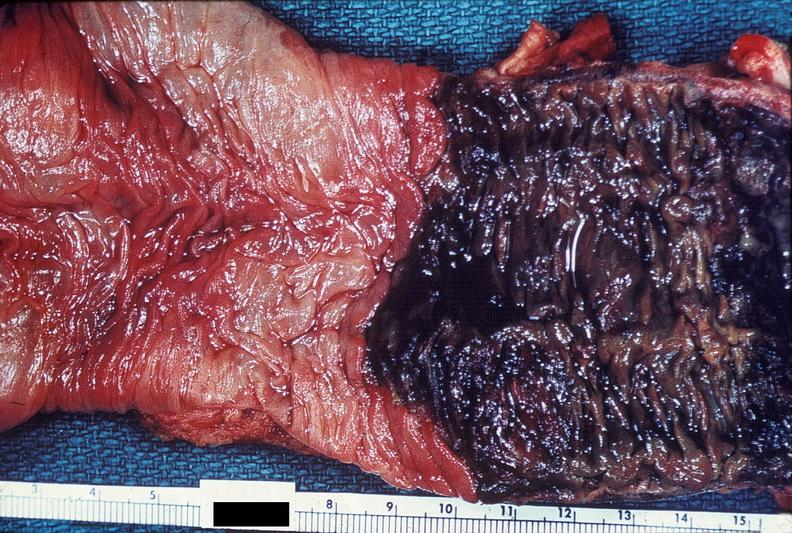where does this belong to?
Answer the question using a single word or phrase. Gastrointestinal system 